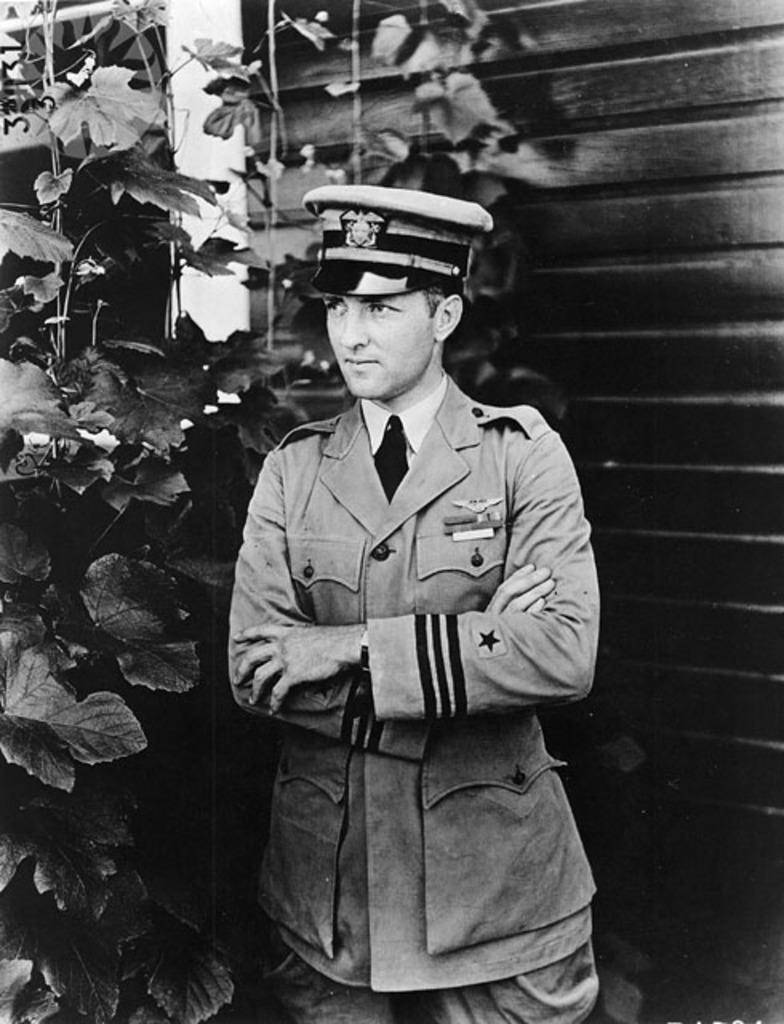What is the color scheme of the image? The image is black and white. What can be seen in the foreground of the image? There is a man standing in the image. What is the man doing in the image? The man is folding his hands. What can be seen in the background of the image? There is a plant, a wall, and a pillar in the background of the image. What type of roof can be seen in the image? There is no roof visible in the image. What is the man teaching in the image? There is no indication in the image that the man is teaching anything. 